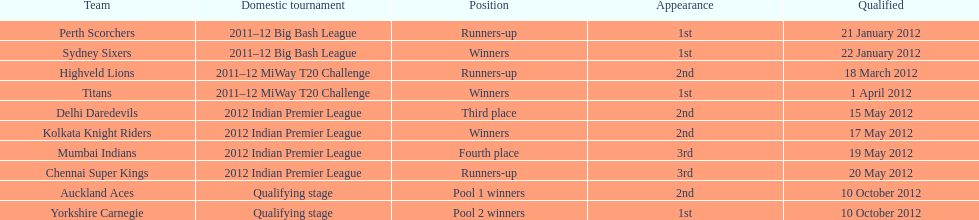The auckland aces and yorkshire carnegie qualified on what date? 10 October 2012. 